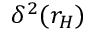<formula> <loc_0><loc_0><loc_500><loc_500>\delta ^ { 2 } ( r _ { H } )</formula> 